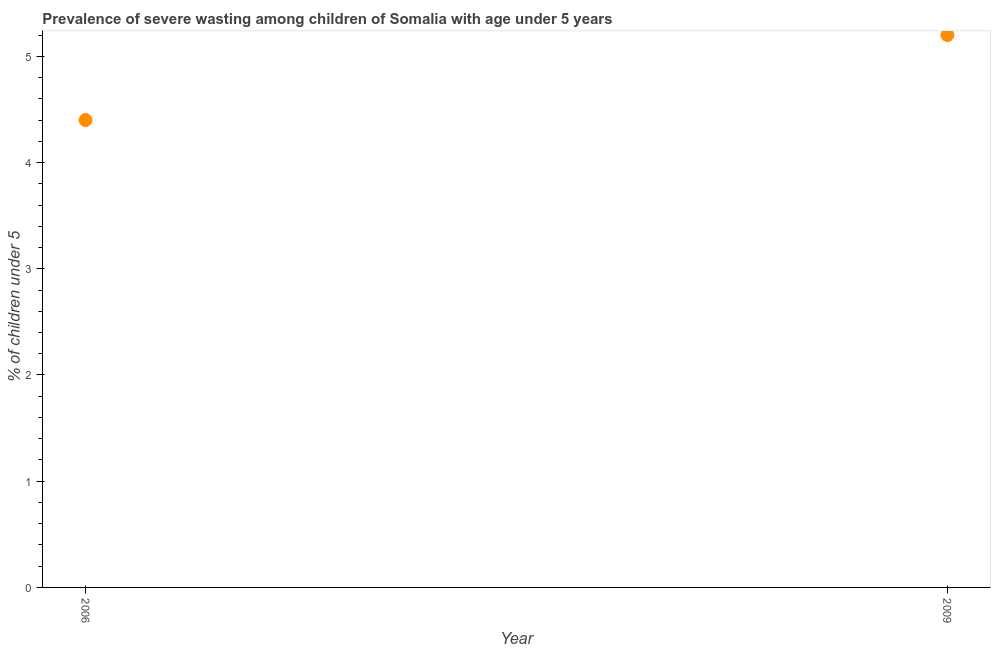What is the prevalence of severe wasting in 2009?
Your response must be concise. 5.2. Across all years, what is the maximum prevalence of severe wasting?
Provide a succinct answer. 5.2. Across all years, what is the minimum prevalence of severe wasting?
Offer a very short reply. 4.4. In which year was the prevalence of severe wasting maximum?
Provide a short and direct response. 2009. What is the sum of the prevalence of severe wasting?
Offer a terse response. 9.6. What is the difference between the prevalence of severe wasting in 2006 and 2009?
Your answer should be very brief. -0.8. What is the average prevalence of severe wasting per year?
Ensure brevity in your answer.  4.8. What is the median prevalence of severe wasting?
Your response must be concise. 4.8. Do a majority of the years between 2009 and 2006 (inclusive) have prevalence of severe wasting greater than 4 %?
Offer a terse response. No. What is the ratio of the prevalence of severe wasting in 2006 to that in 2009?
Your answer should be very brief. 0.85. Is the prevalence of severe wasting in 2006 less than that in 2009?
Provide a short and direct response. Yes. In how many years, is the prevalence of severe wasting greater than the average prevalence of severe wasting taken over all years?
Offer a terse response. 1. Does the prevalence of severe wasting monotonically increase over the years?
Offer a terse response. Yes. How many dotlines are there?
Your response must be concise. 1. How many years are there in the graph?
Your answer should be compact. 2. What is the difference between two consecutive major ticks on the Y-axis?
Offer a terse response. 1. Are the values on the major ticks of Y-axis written in scientific E-notation?
Give a very brief answer. No. What is the title of the graph?
Your answer should be compact. Prevalence of severe wasting among children of Somalia with age under 5 years. What is the label or title of the X-axis?
Offer a very short reply. Year. What is the label or title of the Y-axis?
Keep it short and to the point.  % of children under 5. What is the  % of children under 5 in 2006?
Your response must be concise. 4.4. What is the  % of children under 5 in 2009?
Ensure brevity in your answer.  5.2. What is the difference between the  % of children under 5 in 2006 and 2009?
Your response must be concise. -0.8. What is the ratio of the  % of children under 5 in 2006 to that in 2009?
Ensure brevity in your answer.  0.85. 